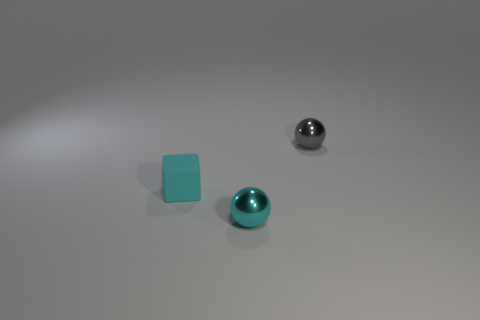What color is the ball that is the same size as the cyan shiny thing?
Ensure brevity in your answer.  Gray. There is a thing that is both behind the tiny cyan metal ball and to the right of the cyan block; what is its color?
Provide a short and direct response. Gray. What is the size of the object that is the same color as the tiny cube?
Your answer should be very brief. Small. The object that is the same color as the small matte block is what shape?
Ensure brevity in your answer.  Sphere. What size is the cyan rubber thing to the left of the metallic sphere that is in front of the ball behind the block?
Offer a terse response. Small. What is the small cube made of?
Offer a very short reply. Rubber. Is the small cyan block made of the same material as the ball that is in front of the small block?
Provide a short and direct response. No. Are there any other things of the same color as the matte thing?
Provide a short and direct response. Yes. There is a small metallic sphere that is to the left of the object right of the tiny cyan metallic object; are there any cyan matte objects that are in front of it?
Offer a terse response. No. Are there any metallic objects to the left of the cyan metal object?
Your answer should be compact. No. 